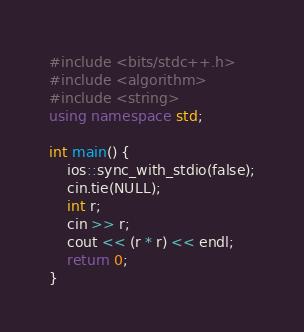<code> <loc_0><loc_0><loc_500><loc_500><_C++_>#include <bits/stdc++.h>
#include <algorithm>
#include <string>
using namespace std;
 
int main() {
    ios::sync_with_stdio(false);
    cin.tie(NULL);
    int r;
    cin >> r;
    cout << (r * r) << endl;
    return 0;
}</code> 